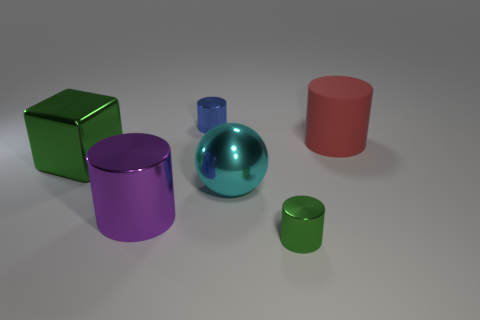There is a thing that is the same color as the block; what shape is it?
Offer a terse response. Cylinder. The other large object that is the same shape as the big purple thing is what color?
Make the answer very short. Red. The green metallic thing that is the same shape as the big red rubber object is what size?
Provide a short and direct response. Small. What material is the object that is on the left side of the small blue object and in front of the big green metallic cube?
Your answer should be very brief. Metal. Do the green metallic object on the right side of the metallic cube and the cyan object have the same size?
Keep it short and to the point. No. Do the big metallic cylinder and the big shiny cube have the same color?
Make the answer very short. No. How many green things are right of the big purple metal cylinder and behind the tiny green shiny cylinder?
Your answer should be compact. 0. There is a tiny cylinder behind the small metal cylinder that is in front of the large purple thing; how many tiny objects are in front of it?
Make the answer very short. 1. The shiny cylinder that is the same color as the large block is what size?
Make the answer very short. Small. What is the shape of the purple thing?
Keep it short and to the point. Cylinder. 